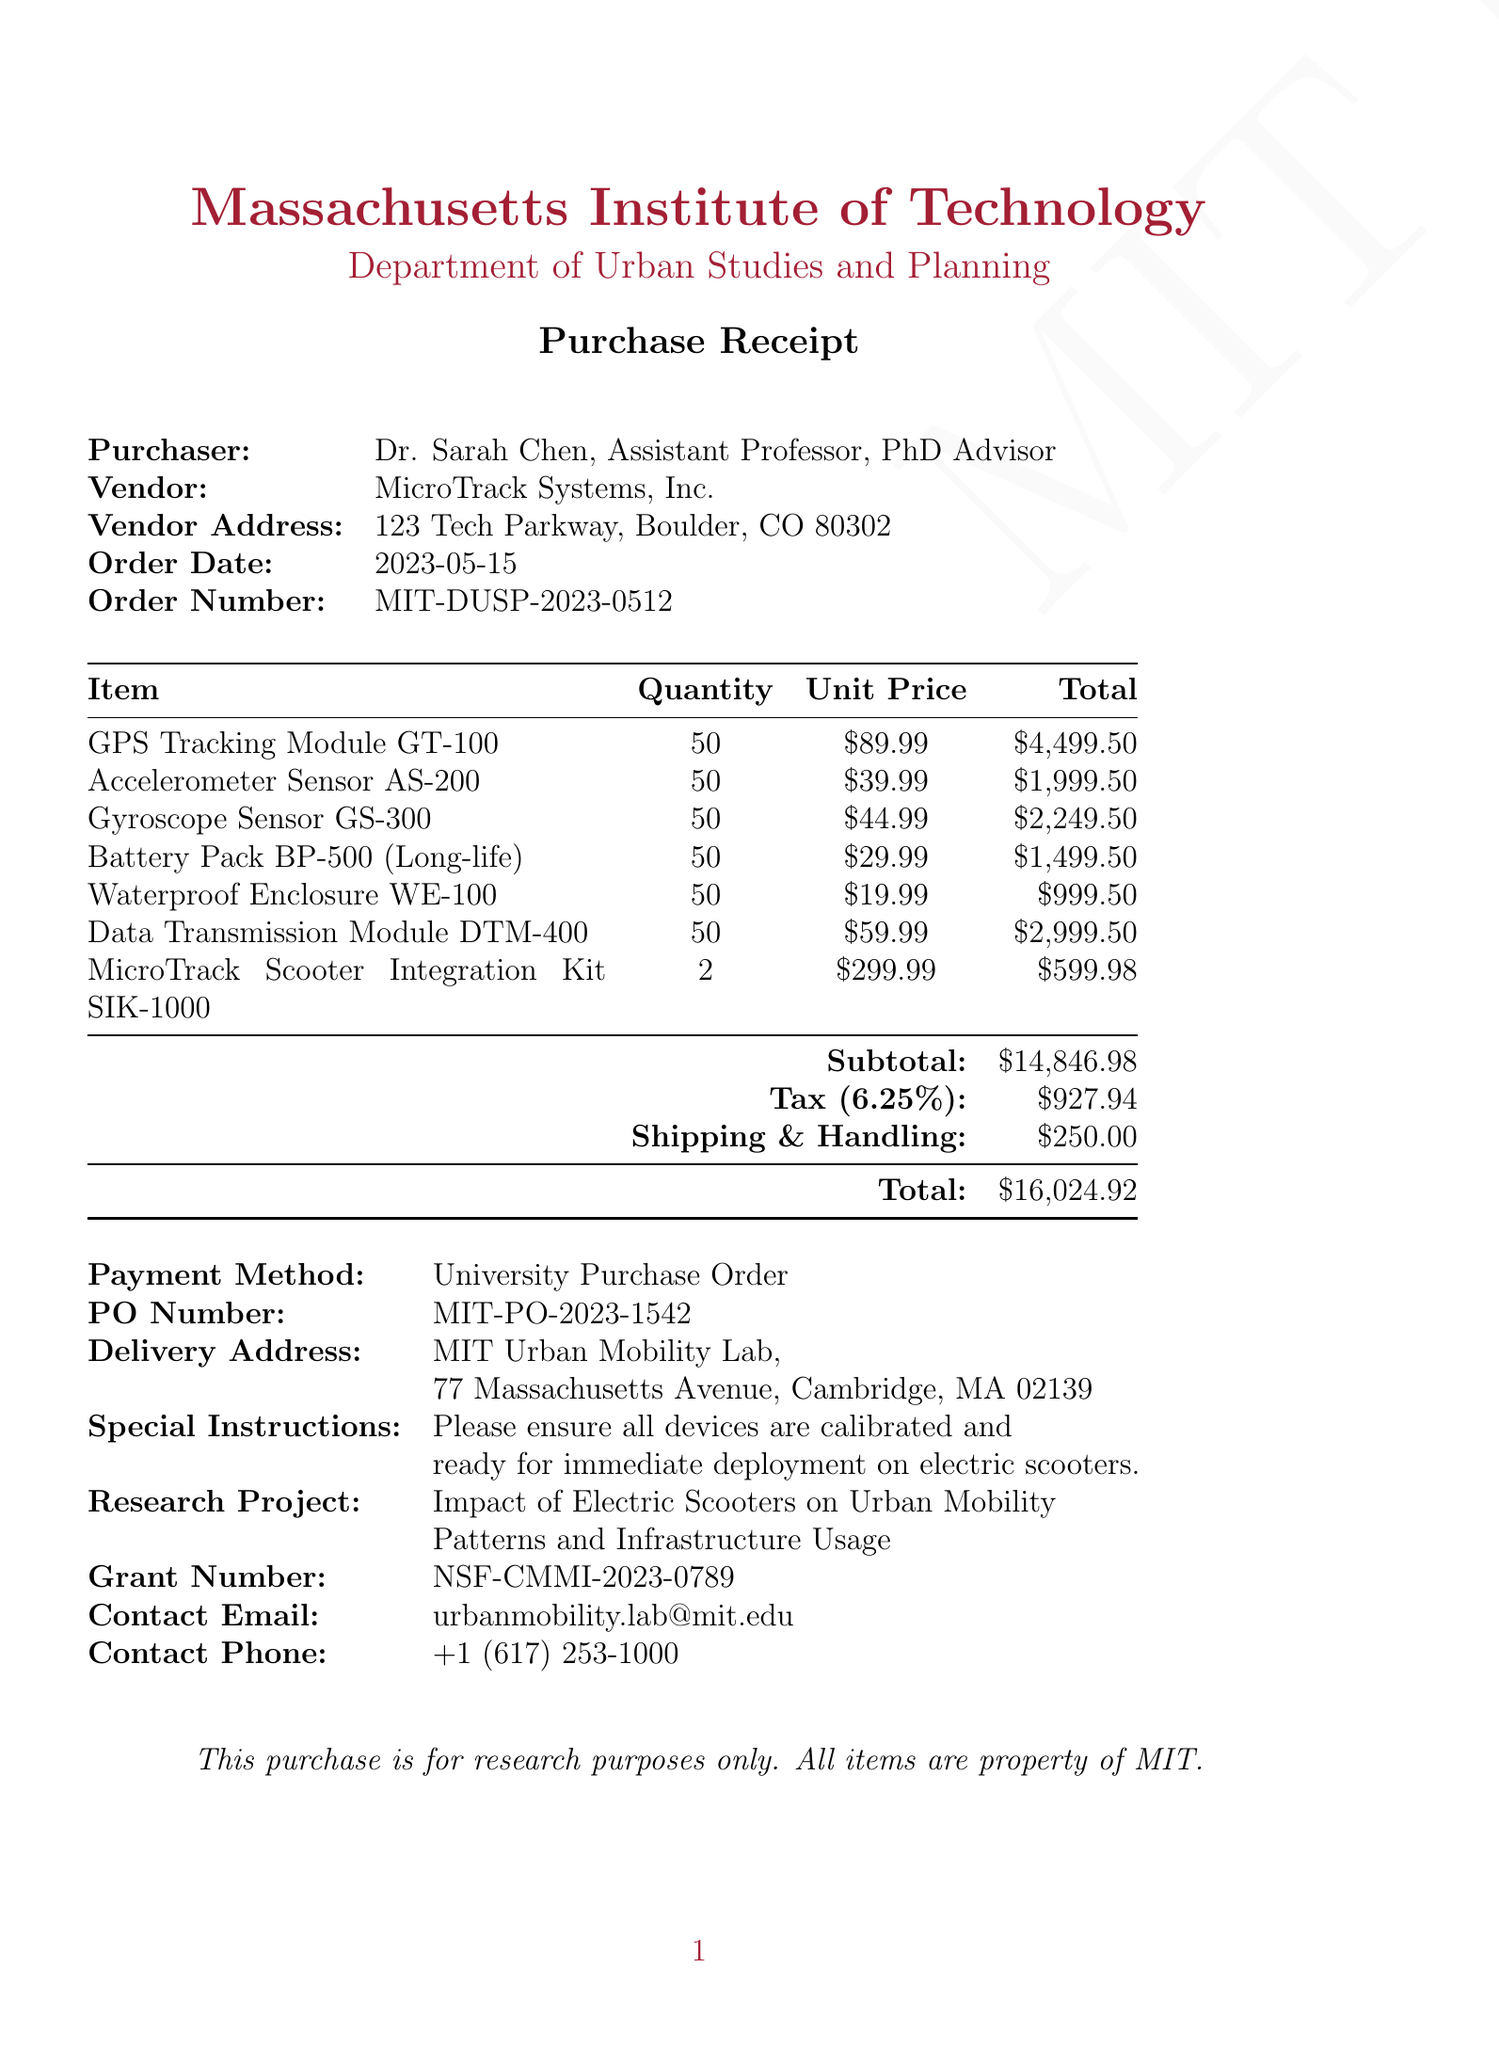What is the vendor name? The vendor name is listed in the document as MicroTrack Systems, Inc.
Answer: MicroTrack Systems, Inc What is the order date? The order date is specified in the document as May 15, 2023.
Answer: 2023-05-15 What is the total amount of the purchase? The total amount is calculated and presented at the end of the document as $16,024.92.
Answer: $16,024.92 What is the quantity of GPS Tracking Modules purchased? The document specifies that 50 GPS Tracking Modules were purchased.
Answer: 50 Who is the purchaser? The purchaser is identified in the document as Dr. Sarah Chen, Assistant Professor, PhD Advisor.
Answer: Dr. Sarah Chen What is the research project associated with this order? The research project details are included, identifying it as Impact of Electric Scooters on Urban Mobility Patterns and Infrastructure Usage.
Answer: Impact of Electric Scooters on Urban Mobility Patterns and Infrastructure Usage What item has the highest unit price? By comparing the unit prices, the item with the highest unit price is the GPS Tracking Module GT-100, at $89.99.
Answer: GPS Tracking Module GT-100 What is the tax amount applied to this purchase? The tax amount is calculated within the document and is stated as $927.94.
Answer: $927.94 What special instructions were provided for the delivery? The document includes special instructions to ensure all devices are calibrated and ready for immediate deployment on electric scooters.
Answer: Please ensure all devices are calibrated and ready for immediate deployment on electric scooters 